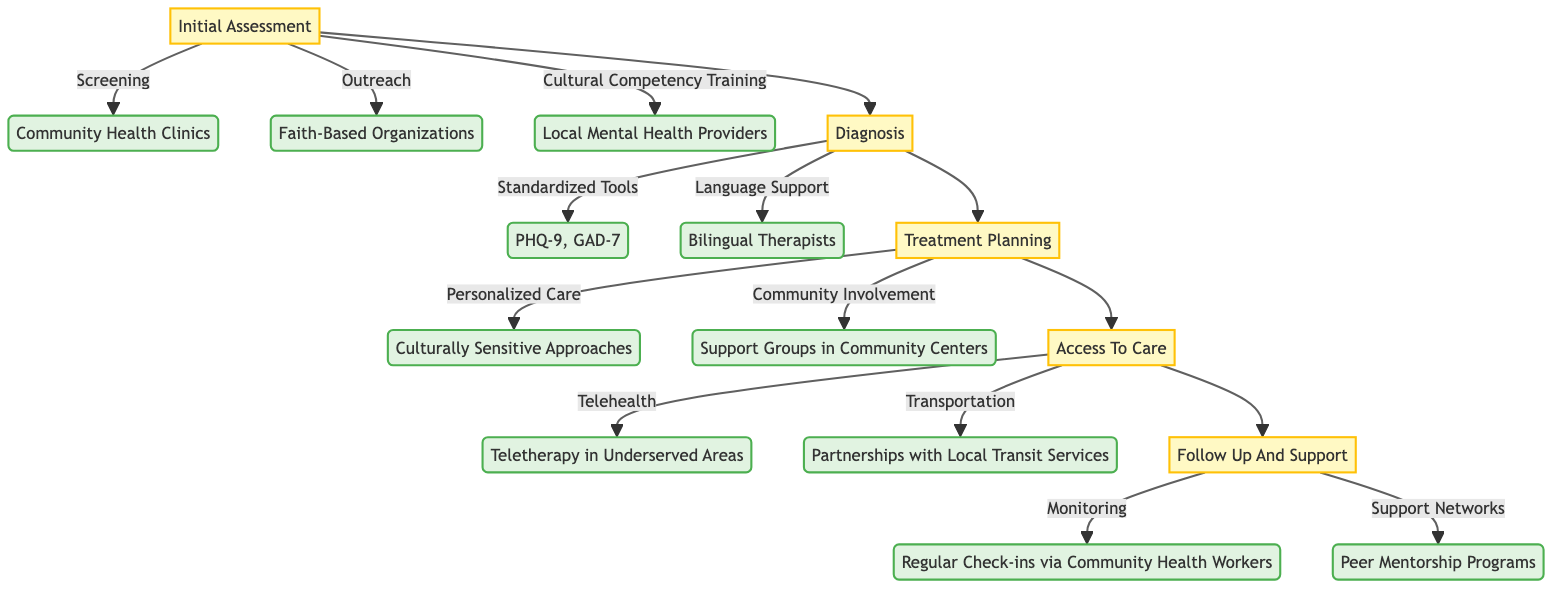What is the first step in the Clinical Pathway? The first step listed in the Clinical Pathway is "Initial Assessment," which serves as the entry point for further actions.
Answer: Initial Assessment Which organization is responsible for Screening? The Screening is handled by "Community Health Clinics," as specified in the diagram.
Answer: Community Health Clinics How many components are under Follow Up And Support? There are two main components under "Follow Up And Support": "Continuous Monitoring" and "Support Networks."
Answer: 2 What types of assessment tools are used for Diagnosis? The standardized assessment tools used for Diagnosis are "PHQ-9" and "GAD-7," indicating two specific tools for mental health evaluation.
Answer: PHQ-9, GAD-7 Which therapy service is aimed specifically at Underserved Areas? The "Teletherapy in Underserved Areas" is the specific service mentioned, indicating a focus on making mental health accessible.
Answer: Teletherapy in Underserved Areas How are Personalized Care Plans described in the Treatment Planning stage? Personalized Care Plans are described as using "Culturally Sensitive Approaches," highlighting the importance of cultural consideration in mental health services.
Answer: Culturally Sensitive Approaches Which two components come under Access To Care? The two components under Access To Care are "Telehealth Services" and "Transportation Assistance," showing the methods to enhance access to mental health care.
Answer: Telehealth Services, Transportation Assistance What support is provided after treatment in the Follow Up stage? After treatment, "Regular Check-ins via Community Health Workers" serve as a support measure to maintain care and monitor progress.
Answer: Regular Check-ins via Community Health Workers What role do Faith-Based Organizations play in the Initial Assessment? Faith-Based Organizations are included under "Outreach," indicating their role in connecting with community members for mental health services.
Answer: Outreach How many steps are indicated before the Follow Up And Support? There are three steps indicated before "Follow Up And Support": Diagnosis, Treatment Planning, and Access To Care, which suggests a structured approach to care.
Answer: 3 